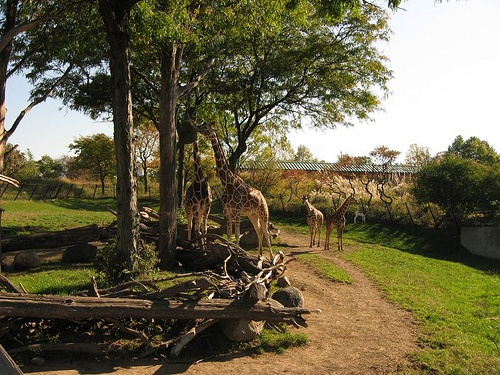Describe the objects in this image and their specific colors. I can see giraffe in darkgreen, black, maroon, and gray tones, giraffe in darkgreen, black, maroon, and gray tones, giraffe in darkgreen, black, maroon, olive, and gray tones, and giraffe in darkgreen, maroon, black, and tan tones in this image. 